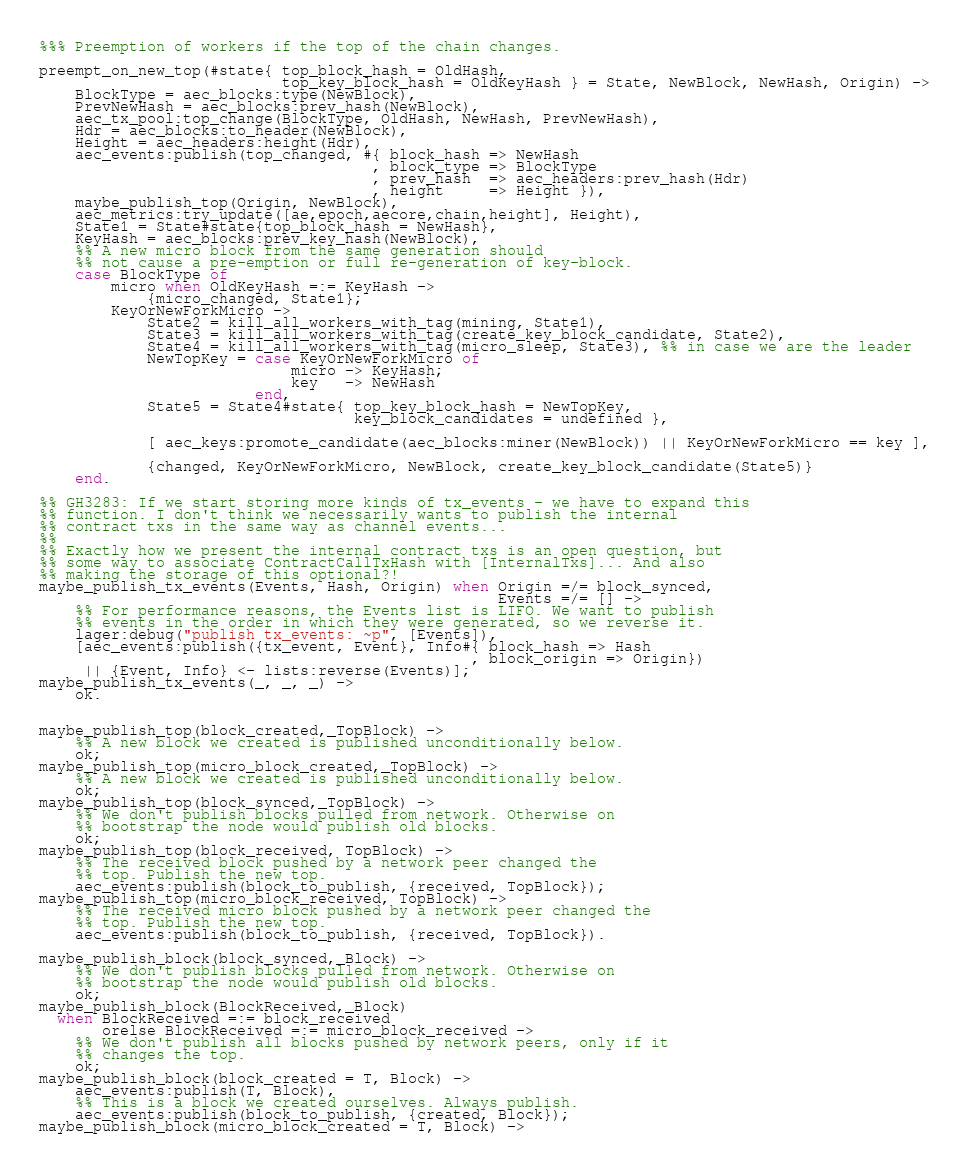Convert code to text. <code><loc_0><loc_0><loc_500><loc_500><_Erlang_>%%% Preemption of workers if the top of the chain changes.

preempt_on_new_top(#state{ top_block_hash = OldHash,
                           top_key_block_hash = OldKeyHash } = State, NewBlock, NewHash, Origin) ->
    BlockType = aec_blocks:type(NewBlock),
    PrevNewHash = aec_blocks:prev_hash(NewBlock),
    aec_tx_pool:top_change(BlockType, OldHash, NewHash, PrevNewHash),
    Hdr = aec_blocks:to_header(NewBlock),
    Height = aec_headers:height(Hdr),
    aec_events:publish(top_changed, #{ block_hash => NewHash
                                     , block_type => BlockType
                                     , prev_hash  => aec_headers:prev_hash(Hdr)
                                     , height     => Height }),
    maybe_publish_top(Origin, NewBlock),
    aec_metrics:try_update([ae,epoch,aecore,chain,height], Height),
    State1 = State#state{top_block_hash = NewHash},
    KeyHash = aec_blocks:prev_key_hash(NewBlock),
    %% A new micro block from the same generation should
    %% not cause a pre-emption or full re-generation of key-block.
    case BlockType of
        micro when OldKeyHash =:= KeyHash ->
            {micro_changed, State1};
        KeyOrNewForkMicro ->
            State2 = kill_all_workers_with_tag(mining, State1),
            State3 = kill_all_workers_with_tag(create_key_block_candidate, State2),
            State4 = kill_all_workers_with_tag(micro_sleep, State3), %% in case we are the leader
            NewTopKey = case KeyOrNewForkMicro of
                            micro -> KeyHash;
                            key   -> NewHash
                        end,
            State5 = State4#state{ top_key_block_hash = NewTopKey,
                                   key_block_candidates = undefined },

            [ aec_keys:promote_candidate(aec_blocks:miner(NewBlock)) || KeyOrNewForkMicro == key ],

            {changed, KeyOrNewForkMicro, NewBlock, create_key_block_candidate(State5)}
    end.

%% GH3283: If we start storing more kinds of tx_events - we have to expand this
%% function. I don't think we necessarily wants to publish the internal
%% contract txs in the same way as channel events...
%%
%% Exactly how we present the internal contract txs is an open question, but
%% some way to associate ContractCallTxHash with [InternalTxs]... And also
%% making the storage of this optional?!
maybe_publish_tx_events(Events, Hash, Origin) when Origin =/= block_synced,
                                                   Events =/= [] ->
    %% For performance reasons, the Events list is LIFO. We want to publish
    %% events in the order in which they were generated, so we reverse it.
    lager:debug("publish tx_events: ~p", [Events]),
    [aec_events:publish({tx_event, Event}, Info#{ block_hash => Hash
                                                , block_origin => Origin})
     || {Event, Info} <- lists:reverse(Events)];
maybe_publish_tx_events(_, _, _) ->
    ok.


maybe_publish_top(block_created,_TopBlock) ->
    %% A new block we created is published unconditionally below.
    ok;
maybe_publish_top(micro_block_created,_TopBlock) ->
    %% A new block we created is published unconditionally below.
    ok;
maybe_publish_top(block_synced,_TopBlock) ->
    %% We don't publish blocks pulled from network. Otherwise on
    %% bootstrap the node would publish old blocks.
    ok;
maybe_publish_top(block_received, TopBlock) ->
    %% The received block pushed by a network peer changed the
    %% top. Publish the new top.
    aec_events:publish(block_to_publish, {received, TopBlock});
maybe_publish_top(micro_block_received, TopBlock) ->
    %% The received micro block pushed by a network peer changed the
    %% top. Publish the new top.
    aec_events:publish(block_to_publish, {received, TopBlock}).

maybe_publish_block(block_synced,_Block) ->
    %% We don't publish blocks pulled from network. Otherwise on
    %% bootstrap the node would publish old blocks.
    ok;
maybe_publish_block(BlockReceived,_Block)
  when BlockReceived =:= block_received
       orelse BlockReceived =:= micro_block_received ->
    %% We don't publish all blocks pushed by network peers, only if it
    %% changes the top.
    ok;
maybe_publish_block(block_created = T, Block) ->
    aec_events:publish(T, Block),
    %% This is a block we created ourselves. Always publish.
    aec_events:publish(block_to_publish, {created, Block});
maybe_publish_block(micro_block_created = T, Block) -></code> 